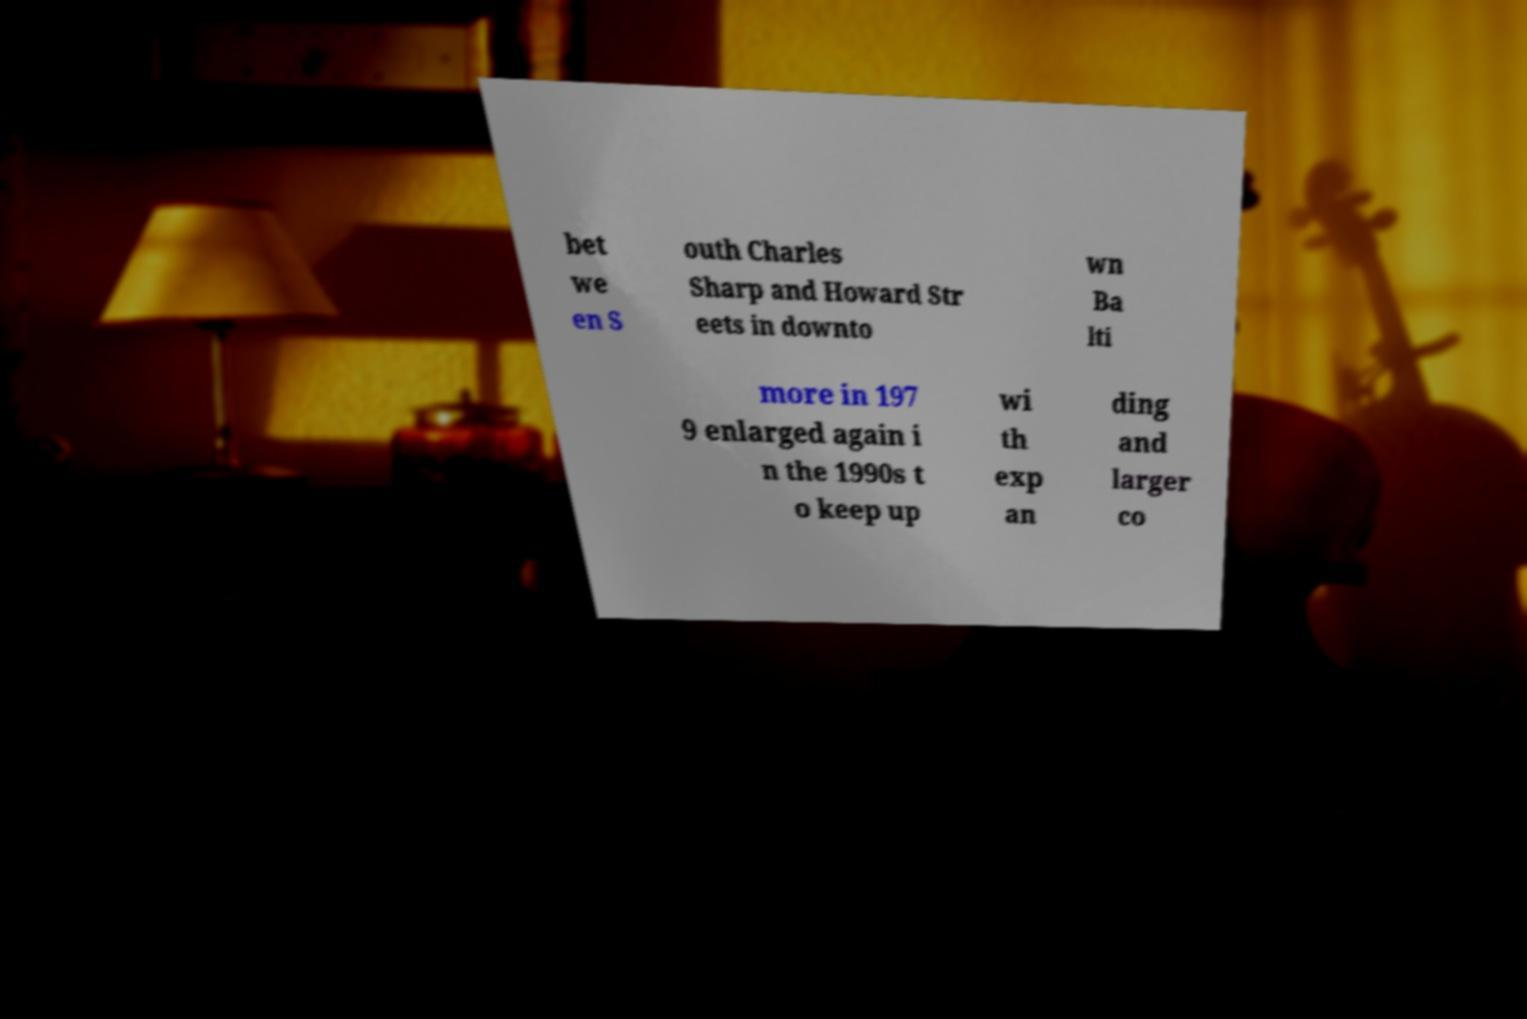Please read and relay the text visible in this image. What does it say? bet we en S outh Charles Sharp and Howard Str eets in downto wn Ba lti more in 197 9 enlarged again i n the 1990s t o keep up wi th exp an ding and larger co 